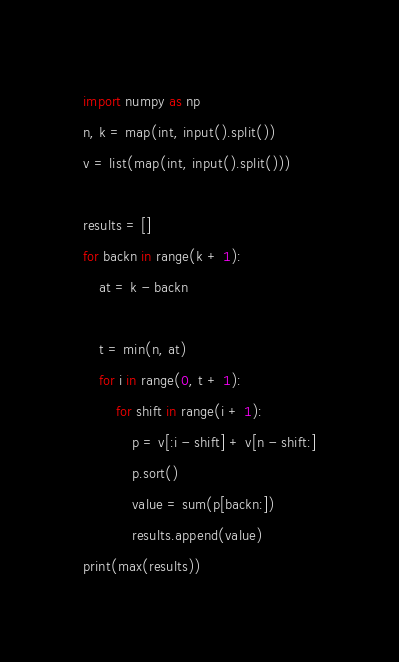<code> <loc_0><loc_0><loc_500><loc_500><_Python_>import numpy as np
n, k = map(int, input().split())
v = list(map(int, input().split()))

results = []
for backn in range(k + 1):
    at = k - backn

    t = min(n, at)
    for i in range(0, t + 1):
        for shift in range(i + 1):
            p = v[:i - shift] + v[n - shift:]
            p.sort()
            value = sum(p[backn:])
            results.append(value)
print(max(results))
</code> 